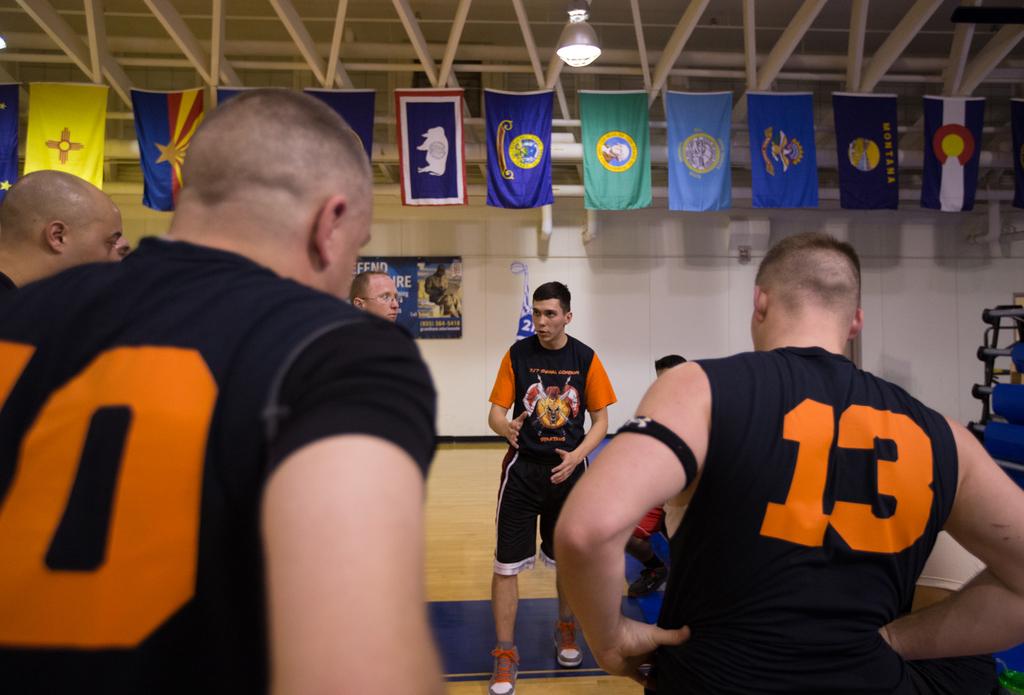What number does the man on the right have on?
Keep it short and to the point. 13. What number is the man on the left wearing?
Your response must be concise. Unanswerable. 